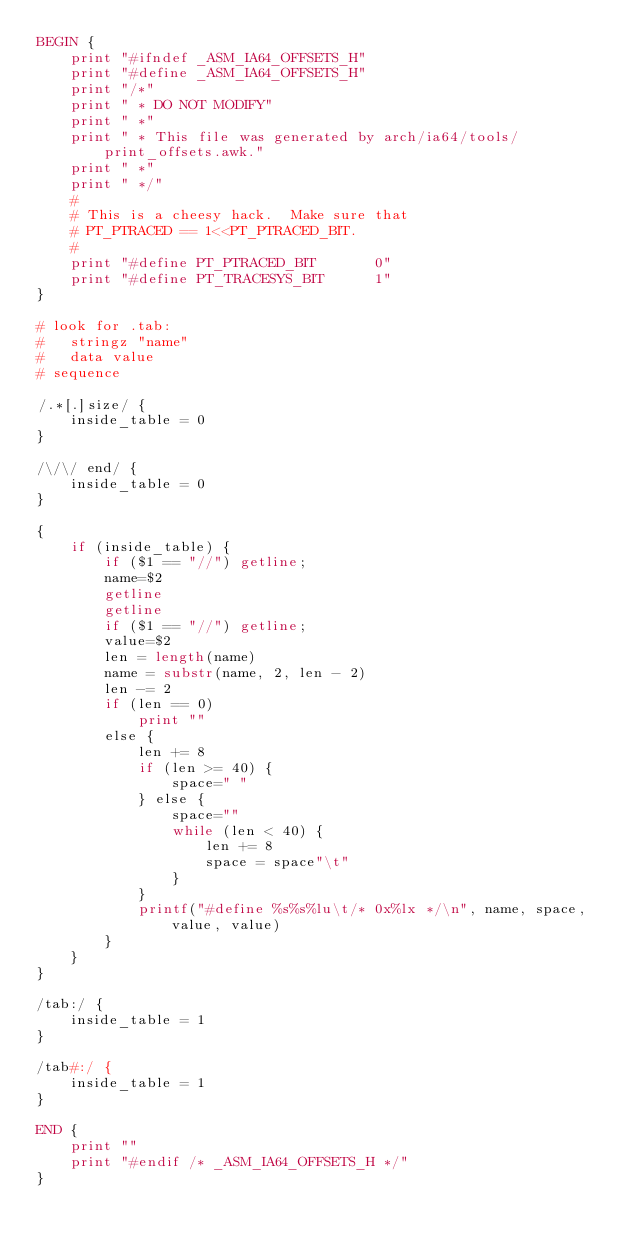<code> <loc_0><loc_0><loc_500><loc_500><_Awk_>BEGIN {
	print "#ifndef _ASM_IA64_OFFSETS_H"
	print "#define _ASM_IA64_OFFSETS_H"
	print "/*"
	print " * DO NOT MODIFY"
	print " *"
	print " * This file was generated by arch/ia64/tools/print_offsets.awk."
	print " *"
	print " */"
	#
	# This is a cheesy hack.  Make sure that
	# PT_PTRACED == 1<<PT_PTRACED_BIT.
	#
	print "#define PT_PTRACED_BIT		0"
	print "#define PT_TRACESYS_BIT		1"
}

# look for .tab:
#	stringz "name"
#	data value
# sequence

/.*[.]size/ {
	inside_table = 0
}

/\/\/ end/ {
	inside_table = 0
}

{
	if (inside_table) {
		if ($1 == "//") getline;
		name=$2
		getline
		getline
		if ($1 == "//") getline;
		value=$2
		len = length(name)
		name = substr(name, 2, len - 2)
		len -= 2
		if (len == 0)
			print ""
		else {
			len += 8
			if (len >= 40) {
				space=" "
			} else {
				space=""
				while (len < 40) {
					len += 8
					space = space"\t"
				}
			}
			printf("#define %s%s%lu\t/* 0x%lx */\n", name, space, value, value)
		}
	}
}

/tab:/ {
	inside_table = 1
}

/tab#:/ {
	inside_table = 1
}

END {
	print ""
	print "#endif /* _ASM_IA64_OFFSETS_H */"
}
</code> 